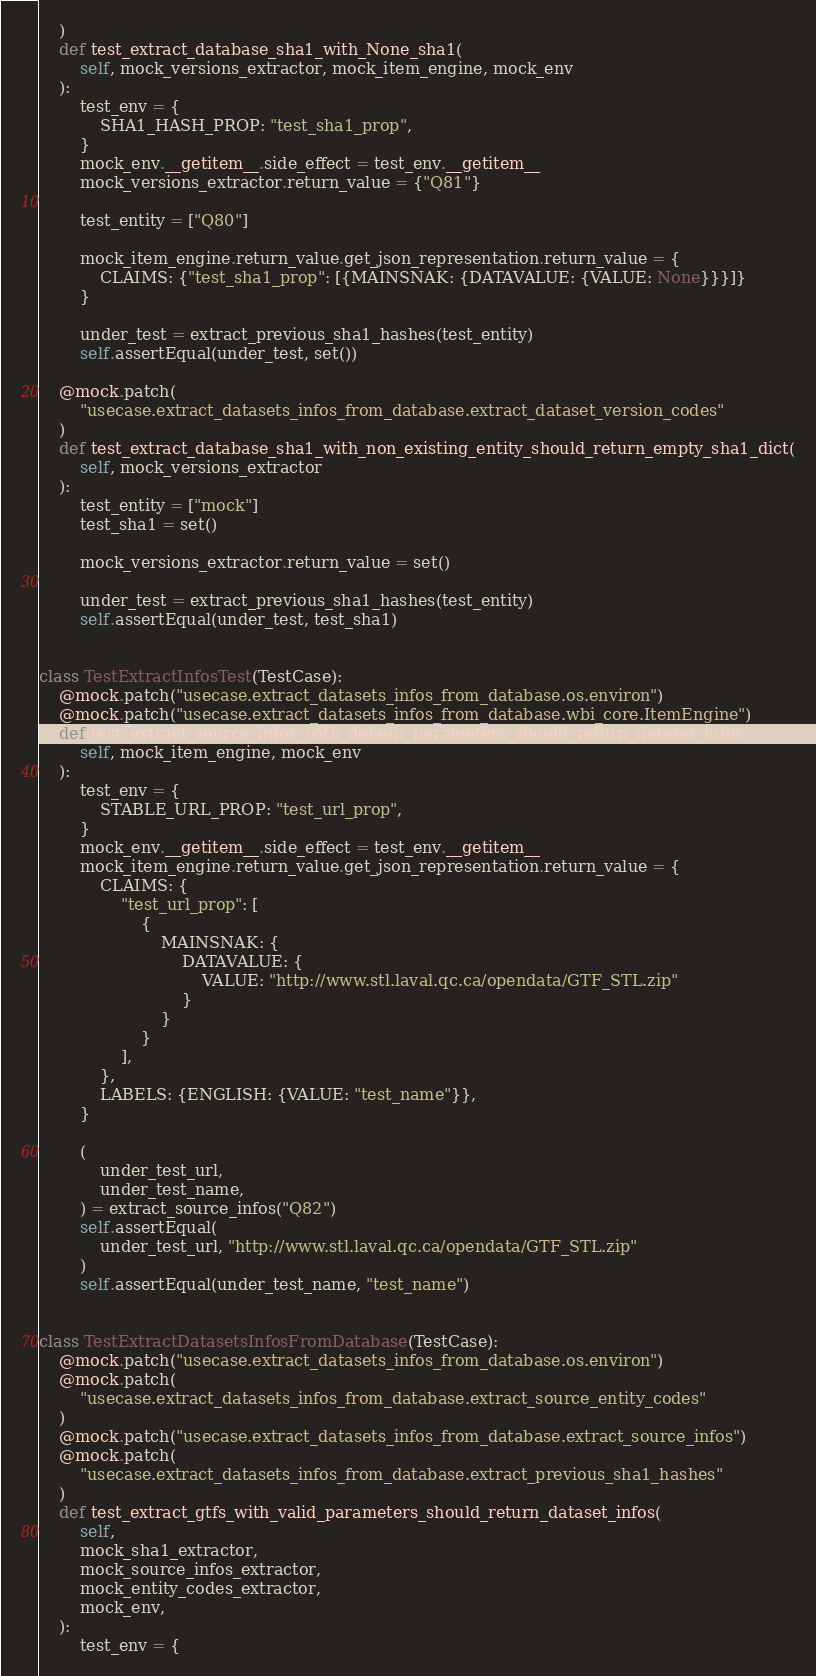Convert code to text. <code><loc_0><loc_0><loc_500><loc_500><_Python_>    )
    def test_extract_database_sha1_with_None_sha1(
        self, mock_versions_extractor, mock_item_engine, mock_env
    ):
        test_env = {
            SHA1_HASH_PROP: "test_sha1_prop",
        }
        mock_env.__getitem__.side_effect = test_env.__getitem__
        mock_versions_extractor.return_value = {"Q81"}

        test_entity = ["Q80"]

        mock_item_engine.return_value.get_json_representation.return_value = {
            CLAIMS: {"test_sha1_prop": [{MAINSNAK: {DATAVALUE: {VALUE: None}}}]}
        }

        under_test = extract_previous_sha1_hashes(test_entity)
        self.assertEqual(under_test, set())

    @mock.patch(
        "usecase.extract_datasets_infos_from_database.extract_dataset_version_codes"
    )
    def test_extract_database_sha1_with_non_existing_entity_should_return_empty_sha1_dict(
        self, mock_versions_extractor
    ):
        test_entity = ["mock"]
        test_sha1 = set()

        mock_versions_extractor.return_value = set()

        under_test = extract_previous_sha1_hashes(test_entity)
        self.assertEqual(under_test, test_sha1)


class TestExtractInfosTest(TestCase):
    @mock.patch("usecase.extract_datasets_infos_from_database.os.environ")
    @mock.patch("usecase.extract_datasets_infos_from_database.wbi_core.ItemEngine")
    def test_extract_source_infos_with_default_parameters_should_return_dataset_infos(
        self, mock_item_engine, mock_env
    ):
        test_env = {
            STABLE_URL_PROP: "test_url_prop",
        }
        mock_env.__getitem__.side_effect = test_env.__getitem__
        mock_item_engine.return_value.get_json_representation.return_value = {
            CLAIMS: {
                "test_url_prop": [
                    {
                        MAINSNAK: {
                            DATAVALUE: {
                                VALUE: "http://www.stl.laval.qc.ca/opendata/GTF_STL.zip"
                            }
                        }
                    }
                ],
            },
            LABELS: {ENGLISH: {VALUE: "test_name"}},
        }

        (
            under_test_url,
            under_test_name,
        ) = extract_source_infos("Q82")
        self.assertEqual(
            under_test_url, "http://www.stl.laval.qc.ca/opendata/GTF_STL.zip"
        )
        self.assertEqual(under_test_name, "test_name")


class TestExtractDatasetsInfosFromDatabase(TestCase):
    @mock.patch("usecase.extract_datasets_infos_from_database.os.environ")
    @mock.patch(
        "usecase.extract_datasets_infos_from_database.extract_source_entity_codes"
    )
    @mock.patch("usecase.extract_datasets_infos_from_database.extract_source_infos")
    @mock.patch(
        "usecase.extract_datasets_infos_from_database.extract_previous_sha1_hashes"
    )
    def test_extract_gtfs_with_valid_parameters_should_return_dataset_infos(
        self,
        mock_sha1_extractor,
        mock_source_infos_extractor,
        mock_entity_codes_extractor,
        mock_env,
    ):
        test_env = {</code> 